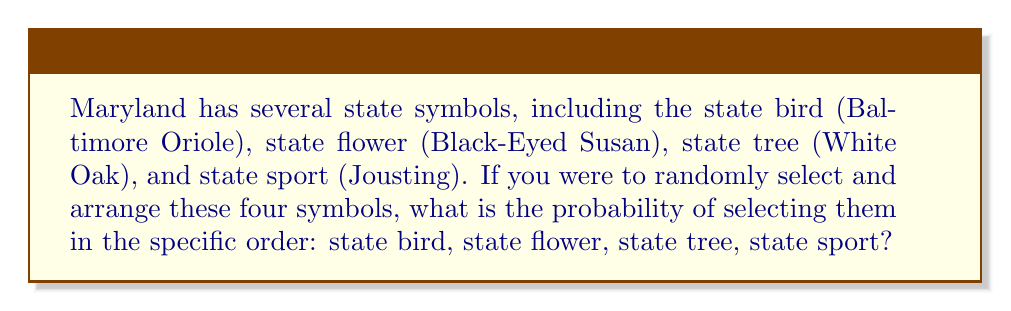Could you help me with this problem? To solve this problem, we'll use the principles of permutations in combinatorics.

1) First, we need to understand that we are dealing with an ordered arrangement of all four symbols. This is a permutation.

2) The total number of possible permutations of 4 distinct objects is:

   $$4! = 4 \times 3 \times 2 \times 1 = 24$$

3) We are interested in only one specific arrangement out of these 24 possibilities.

4) In probability, when all outcomes are equally likely, the probability of a specific outcome is:

   $$P(\text{specific outcome}) = \frac{\text{number of favorable outcomes}}{\text{total number of possible outcomes}}$$

5) In this case:
   - Number of favorable outcomes: 1 (the specific order we want)
   - Total number of possible outcomes: 24

6) Therefore, the probability is:

   $$P(\text{specific order}) = \frac{1}{24} = \frac{1}{4!}$$

This represents the chance of randomly selecting the state symbols in the exact order: Baltimore Oriole, Black-Eyed Susan, White Oak, Jousting.
Answer: $\frac{1}{24}$ 